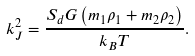<formula> <loc_0><loc_0><loc_500><loc_500>k ^ { 2 } _ { J } = \frac { S _ { d } G \left ( m _ { 1 } \rho _ { 1 } + m _ { 2 } \rho _ { 2 } \right ) } { k _ { B } T } .</formula> 